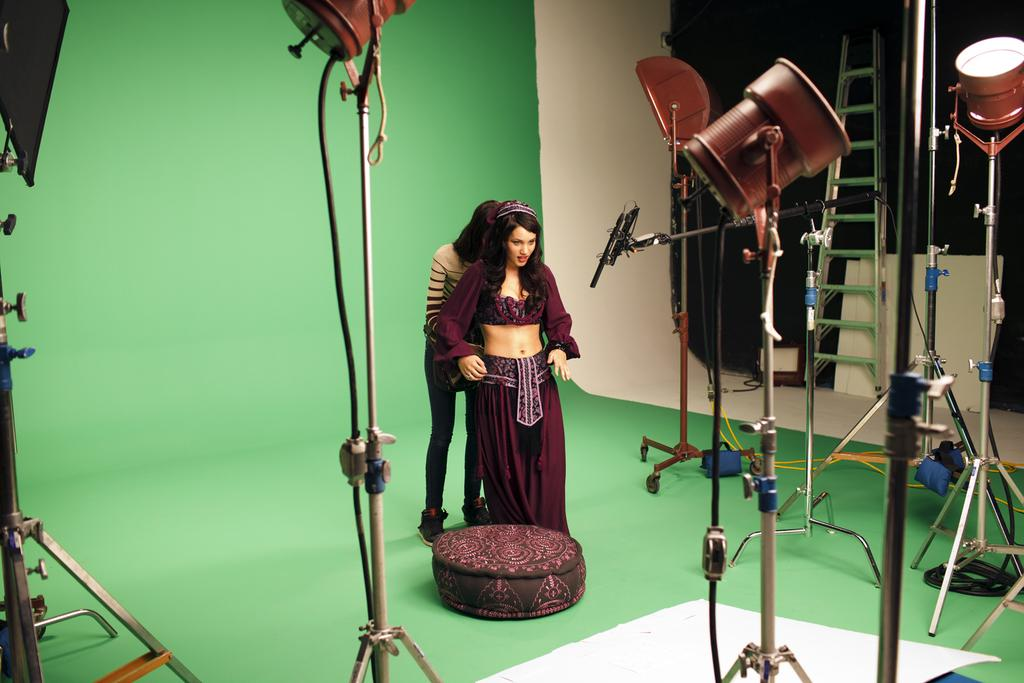How many people are present in the image? There are two people standing in the image. What surface are the people standing on? The people are standing on the floor. What object can be seen in the image that might be used for sitting? There is a stool in the image. What type of lighting is present in the image? There are lights on stands in the image. What additional objects can be seen in the image? There are wires visible in the image. What can be seen in the background of the image? There is a ladder and a wall in the background of the image. What type of meat is being bitten by the person in the image? There is no meat or person biting anything in the image. 